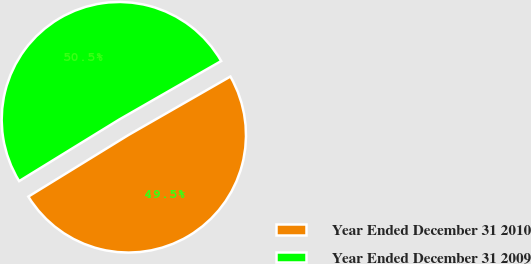Convert chart to OTSL. <chart><loc_0><loc_0><loc_500><loc_500><pie_chart><fcel>Year Ended December 31 2010<fcel>Year Ended December 31 2009<nl><fcel>49.51%<fcel>50.49%<nl></chart> 